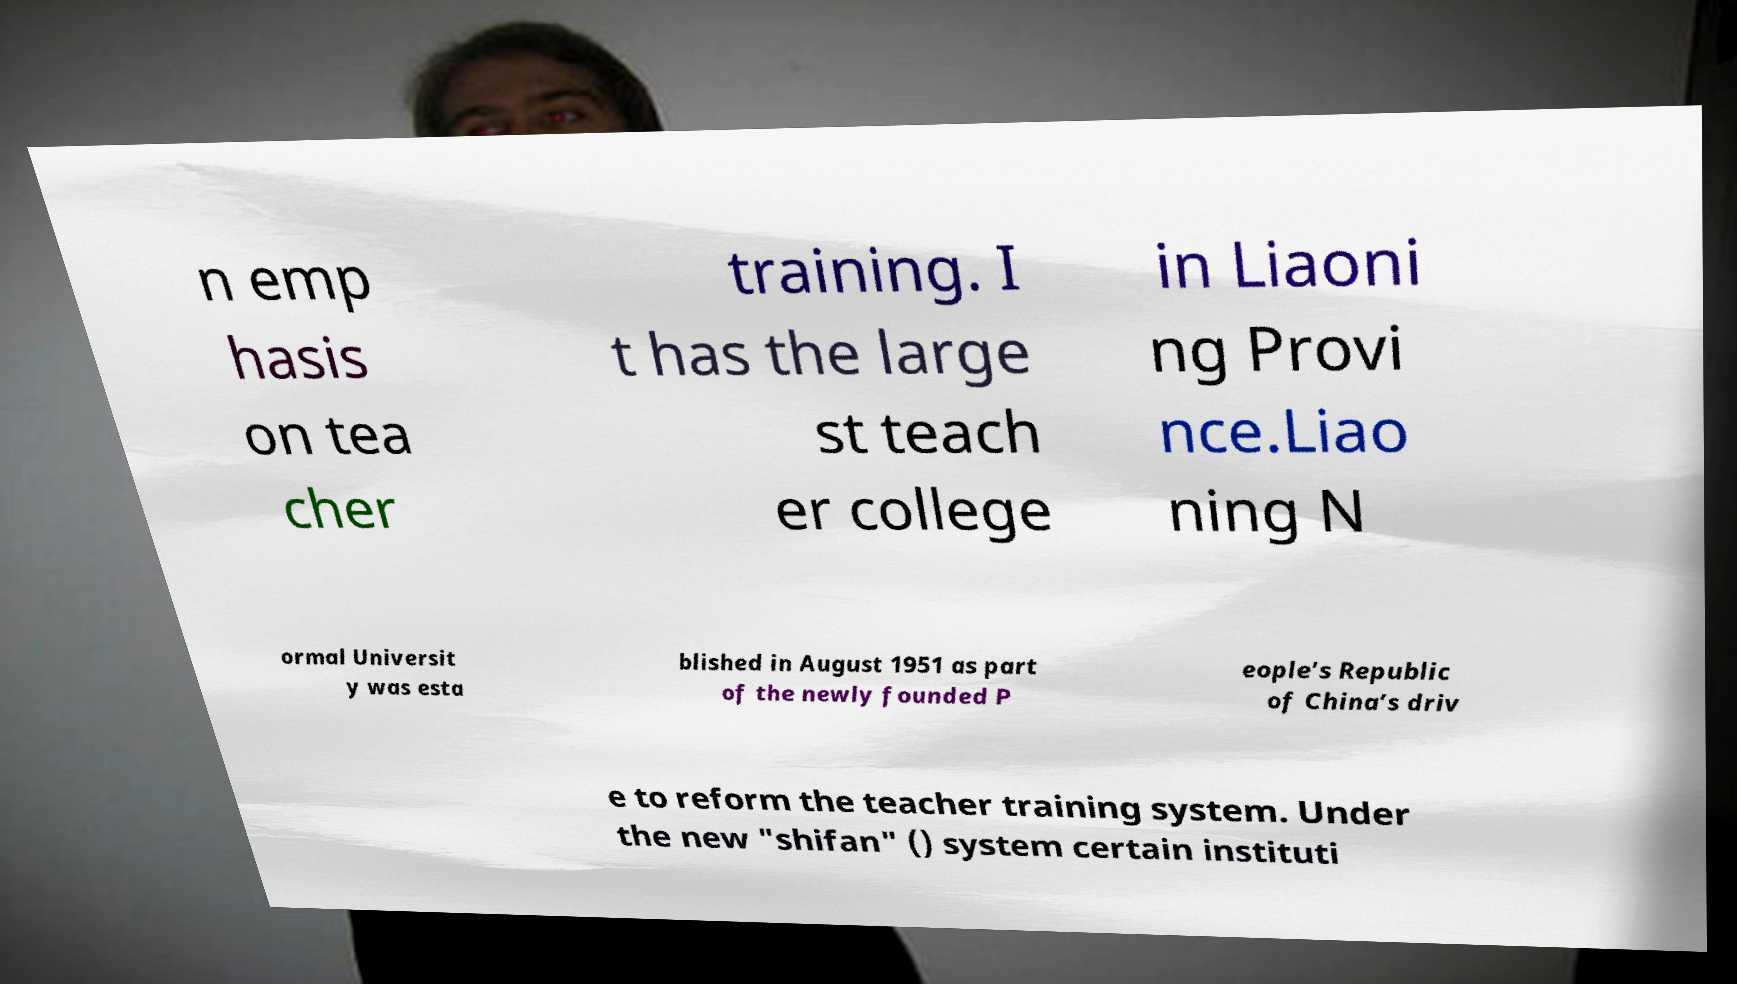Could you assist in decoding the text presented in this image and type it out clearly? n emp hasis on tea cher training. I t has the large st teach er college in Liaoni ng Provi nce.Liao ning N ormal Universit y was esta blished in August 1951 as part of the newly founded P eople’s Republic of China’s driv e to reform the teacher training system. Under the new "shifan" () system certain instituti 